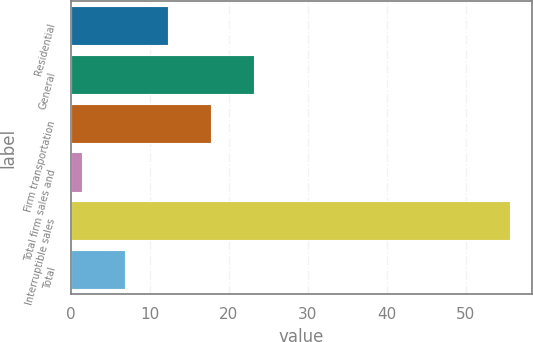Convert chart to OTSL. <chart><loc_0><loc_0><loc_500><loc_500><bar_chart><fcel>Residential<fcel>General<fcel>Firm transportation<fcel>Total firm sales and<fcel>Interruptible sales<fcel>Total<nl><fcel>12.32<fcel>23.14<fcel>17.73<fcel>1.5<fcel>55.6<fcel>6.91<nl></chart> 